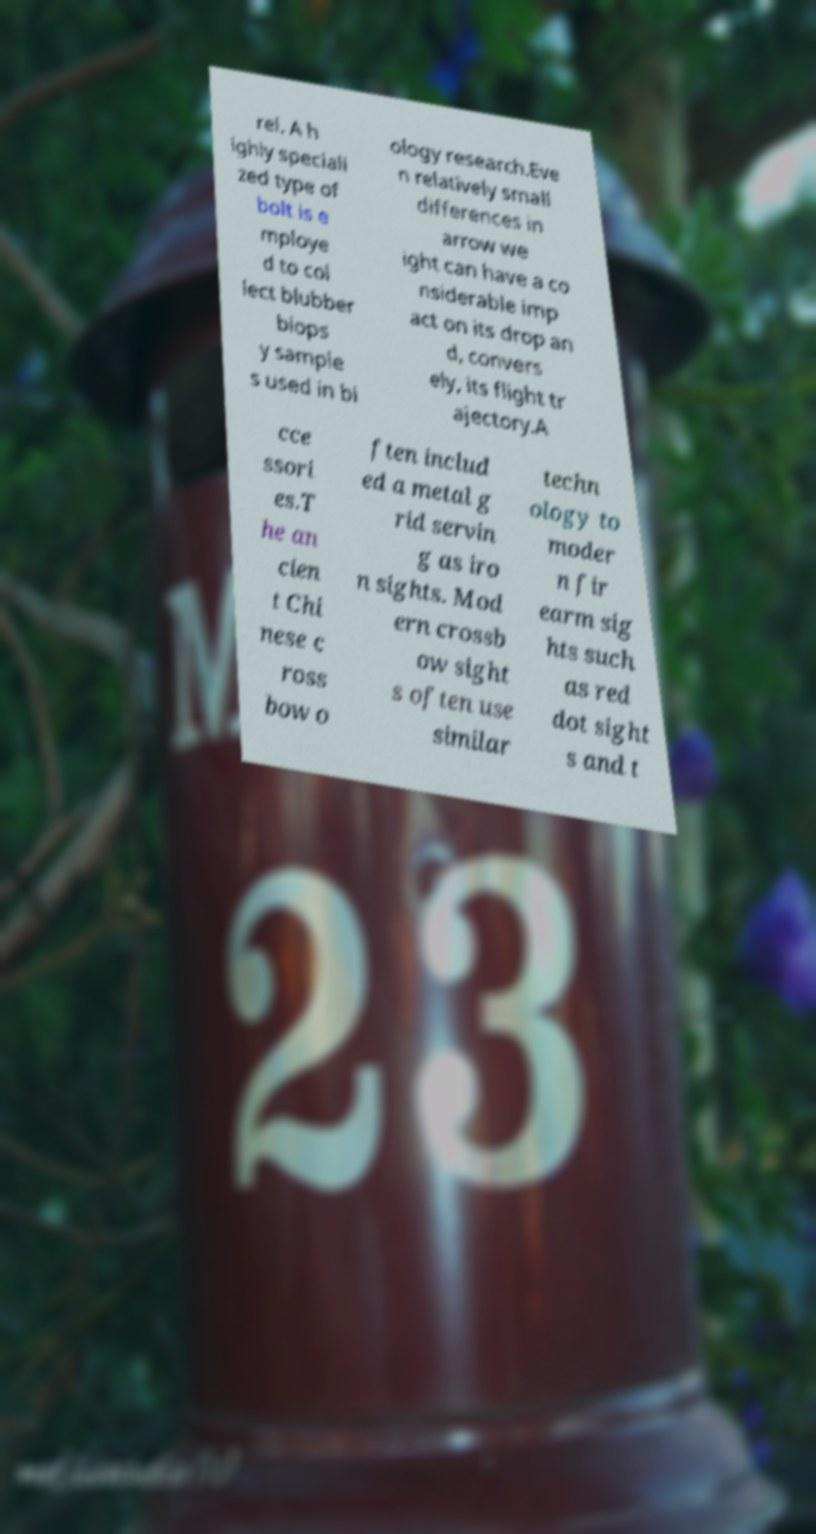What messages or text are displayed in this image? I need them in a readable, typed format. rel. A h ighly speciali zed type of bolt is e mploye d to col lect blubber biops y sample s used in bi ology research.Eve n relatively small differences in arrow we ight can have a co nsiderable imp act on its drop an d, convers ely, its flight tr ajectory.A cce ssori es.T he an cien t Chi nese c ross bow o ften includ ed a metal g rid servin g as iro n sights. Mod ern crossb ow sight s often use similar techn ology to moder n fir earm sig hts such as red dot sight s and t 